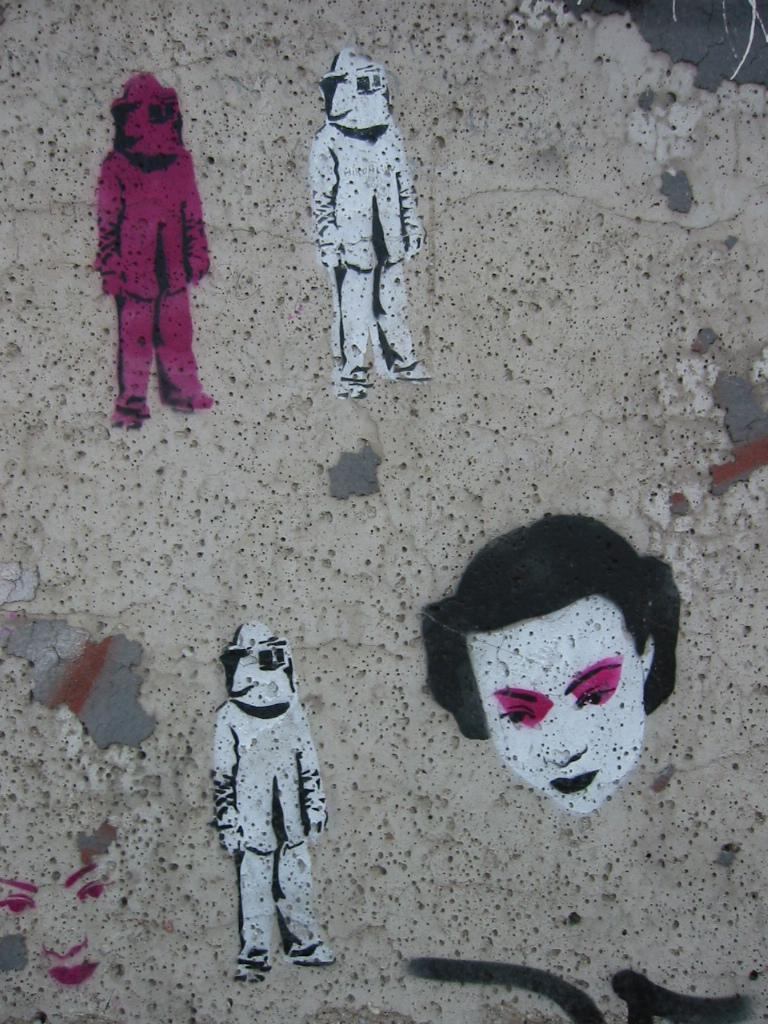What is the main subject of the image? There is a painting in the image. What does the painting depict? The painting depicts four people. Where is the painting located in the image? The painting is on a wall. How many apples are being raked in the image? There are no apples or rakes present in the image; it features a painting of four people. 